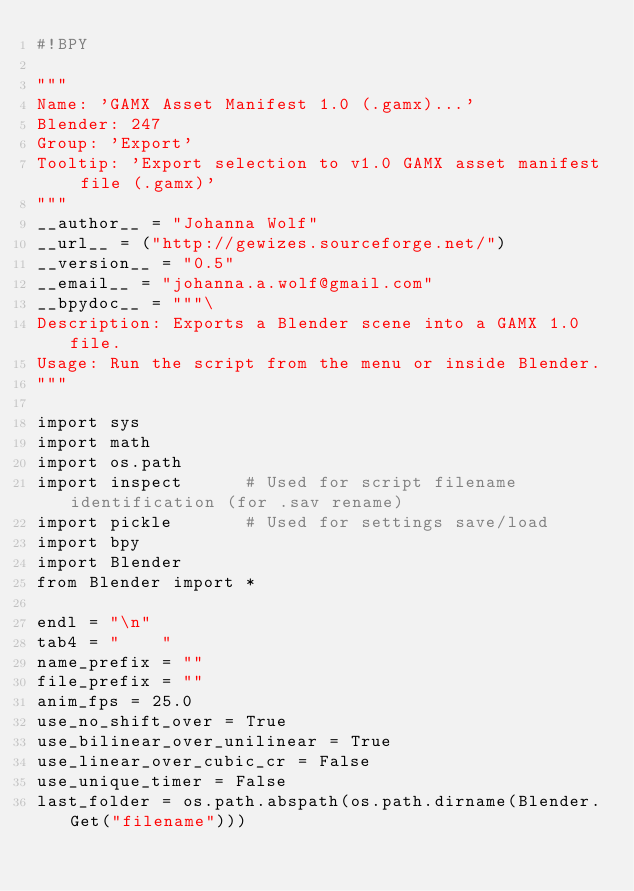Convert code to text. <code><loc_0><loc_0><loc_500><loc_500><_Python_>#!BPY

"""
Name: 'GAMX Asset Manifest 1.0 (.gamx)...'
Blender: 247
Group: 'Export'
Tooltip: 'Export selection to v1.0 GAMX asset manifest file (.gamx)'
"""
__author__ = "Johanna Wolf"
__url__ = ("http://gewizes.sourceforge.net/")
__version__ = "0.5"
__email__ = "johanna.a.wolf@gmail.com"
__bpydoc__ = """\
Description: Exports a Blender scene into a GAMX 1.0 file.
Usage: Run the script from the menu or inside Blender. 
"""

import sys
import math
import os.path
import inspect      # Used for script filename identification (for .sav rename)
import pickle       # Used for settings save/load
import bpy
import Blender
from Blender import *

endl = "\n"
tab4 = "    "
name_prefix = ""
file_prefix = ""
anim_fps = 25.0
use_no_shift_over = True
use_bilinear_over_unilinear = True
use_linear_over_cubic_cr = False
use_unique_timer = False
last_folder = os.path.abspath(os.path.dirname(Blender.Get("filename")))
</code> 